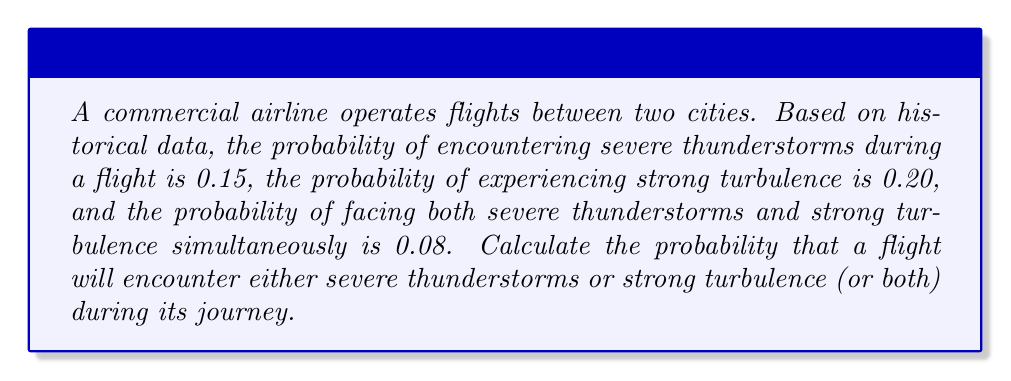What is the answer to this math problem? To solve this problem, we'll use the concept of probability of union of events and the addition rule of probability.

Let's define our events:
A = Severe thunderstorms
B = Strong turbulence

We're given:
P(A) = 0.15
P(B) = 0.20
P(A ∩ B) = 0.08

We want to find P(A ∪ B), which is the probability of either A or B (or both) occurring.

The addition rule of probability states:

$$ P(A \cup B) = P(A) + P(B) - P(A \cap B) $$

This rule accounts for the overlap between events A and B to avoid double-counting.

Substituting our known values:

$$ P(A \cup B) = 0.15 + 0.20 - 0.08 $$

$$ P(A \cup B) = 0.35 - 0.08 $$

$$ P(A \cup B) = 0.27 $$

Therefore, the probability that a flight will encounter either severe thunderstorms or strong turbulence (or both) is 0.27 or 27%.
Answer: 0.27 or 27% 